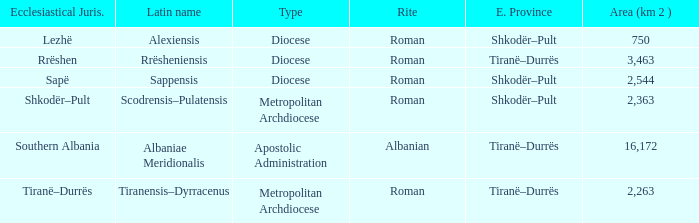Can you give me this table as a dict? {'header': ['Ecclesiastical Juris.', 'Latin name', 'Type', 'Rite', 'E. Province', 'Area (km 2 )'], 'rows': [['Lezhë', 'Alexiensis', 'Diocese', 'Roman', 'Shkodër–Pult', '750'], ['Rrëshen', 'Rrësheniensis', 'Diocese', 'Roman', 'Tiranë–Durrës', '3,463'], ['Sapë', 'Sappensis', 'Diocese', 'Roman', 'Shkodër–Pult', '2,544'], ['Shkodër–Pult', 'Scodrensis–Pulatensis', 'Metropolitan Archdiocese', 'Roman', 'Shkodër–Pult', '2,363'], ['Southern Albania', 'Albaniae Meridionalis', 'Apostolic Administration', 'Albanian', 'Tiranë–Durrës', '16,172'], ['Tiranë–Durrës', 'Tiranensis–Dyrracenus', 'Metropolitan Archdiocese', 'Roman', 'Tiranë–Durrës', '2,263']]} What Area (km 2) is lowest with a type being Apostolic Administration? 16172.0. 